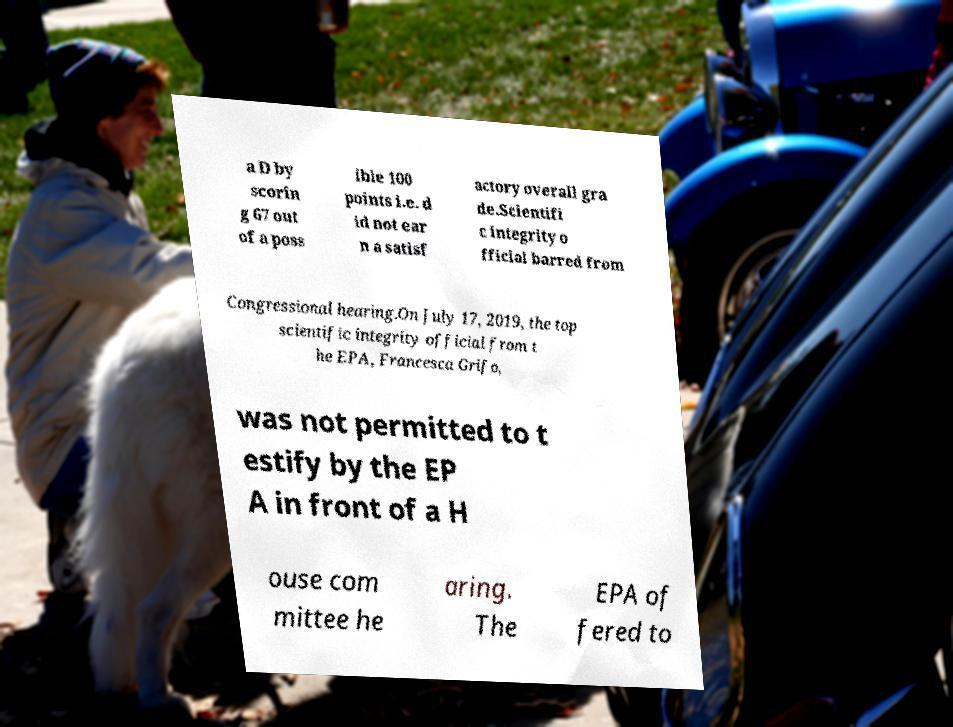What messages or text are displayed in this image? I need them in a readable, typed format. a D by scorin g 67 out of a poss ible 100 points i.e. d id not ear n a satisf actory overall gra de.Scientifi c integrity o fficial barred from Congressional hearing.On July 17, 2019, the top scientific integrity official from t he EPA, Francesca Grifo, was not permitted to t estify by the EP A in front of a H ouse com mittee he aring. The EPA of fered to 